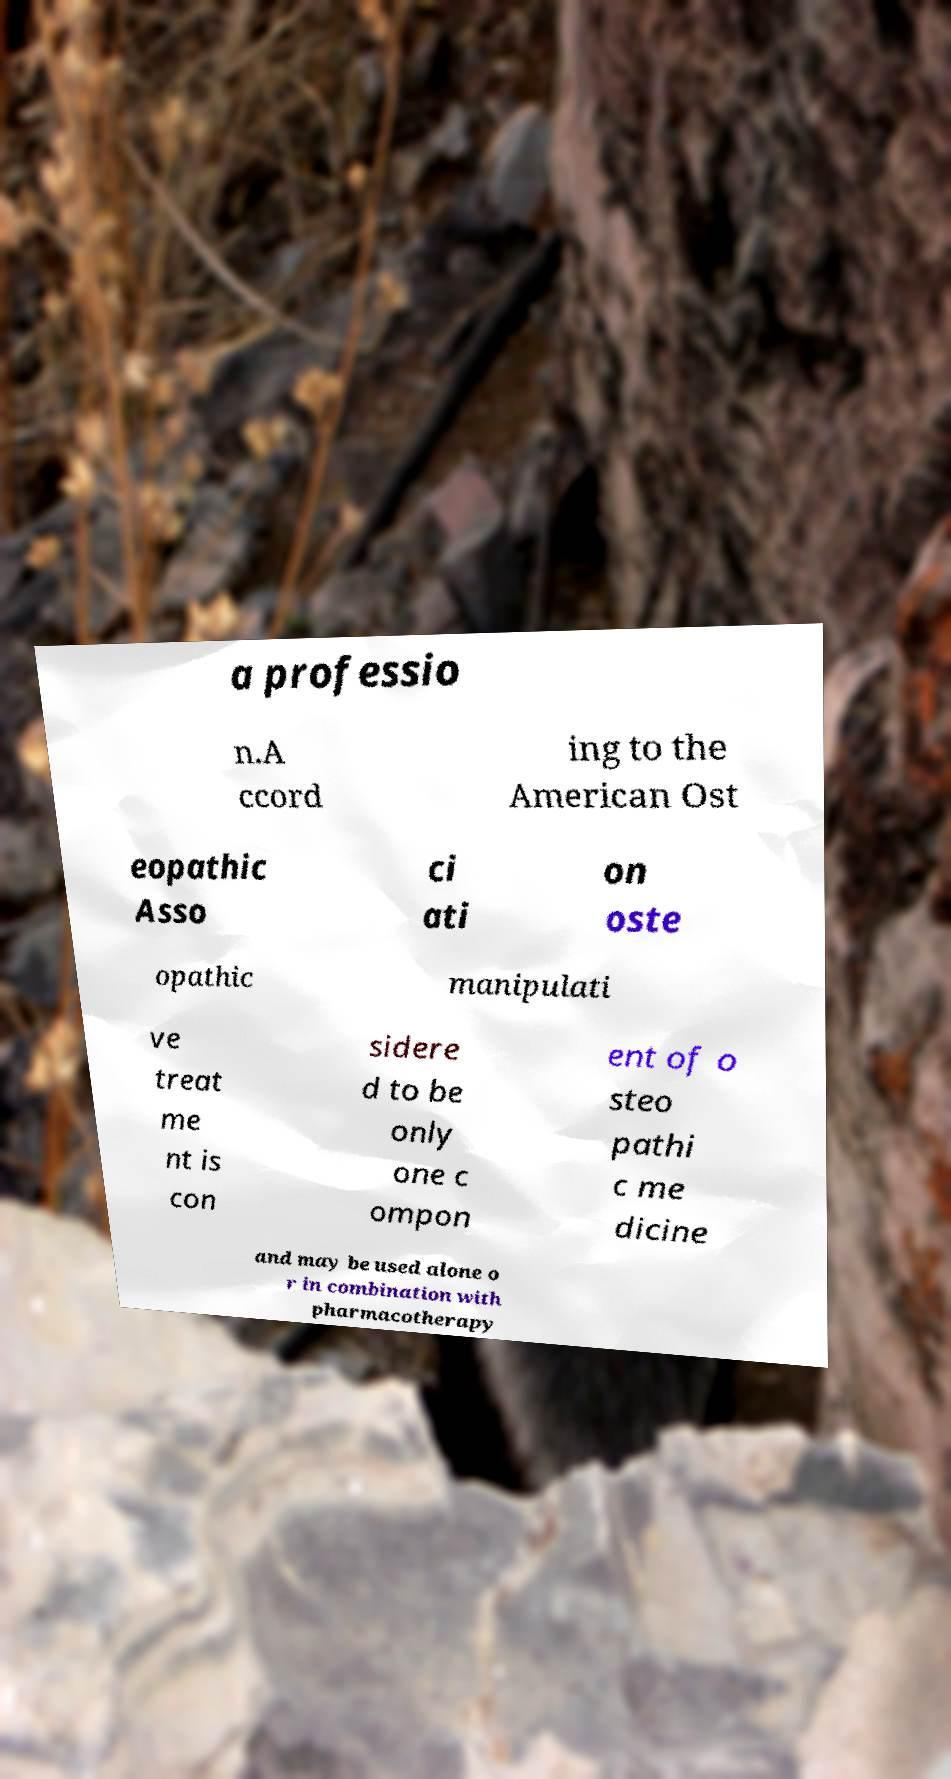There's text embedded in this image that I need extracted. Can you transcribe it verbatim? a professio n.A ccord ing to the American Ost eopathic Asso ci ati on oste opathic manipulati ve treat me nt is con sidere d to be only one c ompon ent of o steo pathi c me dicine and may be used alone o r in combination with pharmacotherapy 